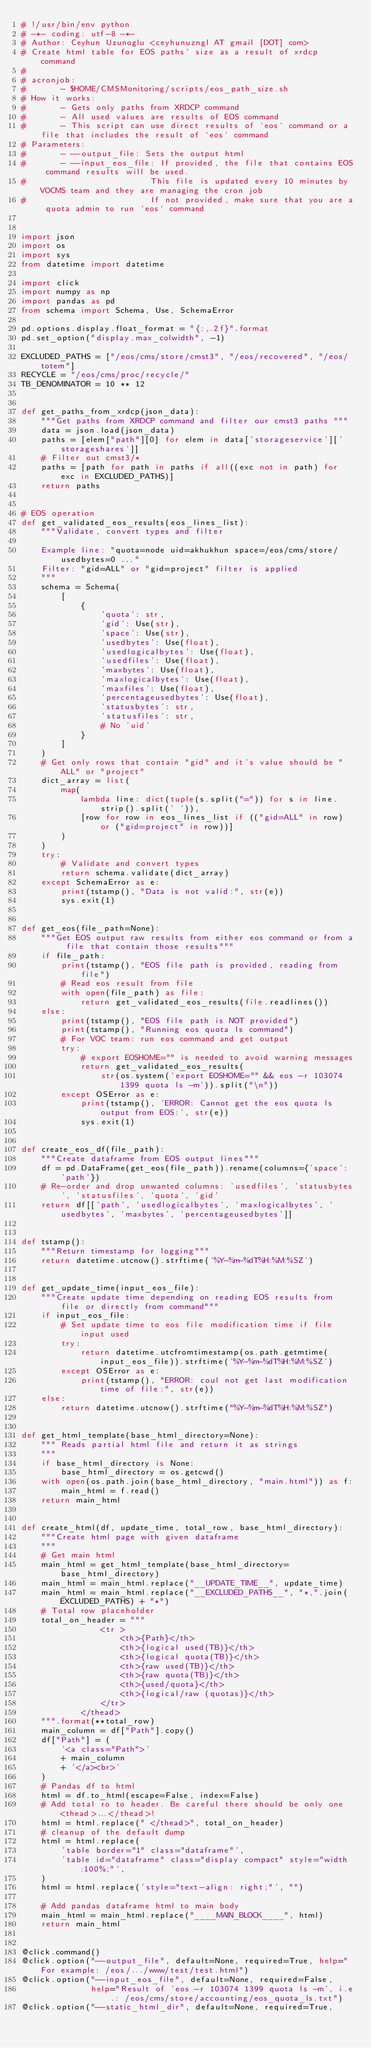Convert code to text. <code><loc_0><loc_0><loc_500><loc_500><_Python_># !/usr/bin/env python
# -*- coding: utf-8 -*-
# Author: Ceyhun Uzunoglu <ceyhunuzngl AT gmail [DOT] com>
# Create html table for EOS paths' size as a result of xrdcp command
#
# acronjob:
#       - $HOME/CMSMonitoring/scripts/eos_path_size.sh
# How it works:
#       - Gets only paths from XRDCP command
#       - All used values are results of EOS command
#       - This script can use direct results of `eos` command or a file that includes the result of `eos` command
# Parameters:
#       - --output_file: Sets the output html
#       - --input_eos_file: If provided, the file that contains EOS command results will be used.
#                         This file is updated every 10 minutes by VOCMS team and they are managing the cron job
#                         If not provided, make sure that you are a quota admin to run `eos` command


import json
import os
import sys
from datetime import datetime

import click
import numpy as np
import pandas as pd
from schema import Schema, Use, SchemaError

pd.options.display.float_format = "{:,.2f}".format
pd.set_option("display.max_colwidth", -1)

EXCLUDED_PATHS = ["/eos/cms/store/cmst3", "/eos/recovered", "/eos/totem"]
RECYCLE = "/eos/cms/proc/recycle/"
TB_DENOMINATOR = 10 ** 12


def get_paths_from_xrdcp(json_data):
    """Get paths from XRDCP command and filter our cmst3 paths """
    data = json.load(json_data)
    paths = [elem["path"][0] for elem in data['storageservice']['storageshares']]
    # Filter out cmst3/*
    paths = [path for path in paths if all((exc not in path) for exc in EXCLUDED_PATHS)]
    return paths


# EOS operation
def get_validated_eos_results(eos_lines_list):
    """Validate, convert types and filter

    Example line: "quota=node uid=akhukhun space=/eos/cms/store/ usedbytes=0 ..."
    Filter: "gid=ALL" or "gid=project" filter is applied
    """
    schema = Schema(
        [
            {
                'quota': str,
                'gid': Use(str),
                'space': Use(str),
                'usedbytes': Use(float),
                'usedlogicalbytes': Use(float),
                'usedfiles': Use(float),
                'maxbytes': Use(float),
                'maxlogicalbytes': Use(float),
                'maxfiles': Use(float),
                'percentageusedbytes': Use(float),
                'statusbytes': str,
                'statusfiles': str,
                # No 'uid'
            }
        ]
    )
    # Get only rows that contain "gid" and it's value should be "ALL" or "project"
    dict_array = list(
        map(
            lambda line: dict(tuple(s.split("=")) for s in line.strip().split(' ')),
            [row for row in eos_lines_list if (("gid=ALL" in row) or ("gid=project" in row))]
        )
    )
    try:
        # Validate and convert types
        return schema.validate(dict_array)
    except SchemaError as e:
        print(tstamp(), "Data is not valid:", str(e))
        sys.exit(1)


def get_eos(file_path=None):
    """Get EOS output raw results from either eos command or from a file that contain those results"""
    if file_path:
        print(tstamp(), "EOS file path is provided, reading from file")
        # Read eos result from file
        with open(file_path) as file:
            return get_validated_eos_results(file.readlines())
    else:
        print(tstamp(), "EOS file path is NOT provided")
        print(tstamp(), "Running eos quota ls command")
        # For VOC team: run eos command and get output
        try:
            # export EOSHOME="" is needed to avoid warning messages
            return get_validated_eos_results(
                str(os.system('export EOSHOME="" && eos -r 103074 1399 quota ls -m')).split("\n"))
        except OSError as e:
            print(tstamp(), 'ERROR: Cannot get the eos quota ls output from EOS:', str(e))
            sys.exit(1)


def create_eos_df(file_path):
    """Create dataframe from EOS output lines"""
    df = pd.DataFrame(get_eos(file_path)).rename(columns={'space': 'path'})
    # Re-order and drop unwanted columns: 'usedfiles', 'statusbytes', 'statusfiles', 'quota', 'gid'
    return df[['path', 'usedlogicalbytes', 'maxlogicalbytes', 'usedbytes', 'maxbytes', 'percentageusedbytes']]


def tstamp():
    """Return timestamp for logging"""
    return datetime.utcnow().strftime('%Y-%m-%dT%H:%M:%SZ')


def get_update_time(input_eos_file):
    """Create update time depending on reading EOS results from file or directly from command"""
    if input_eos_file:
        # Set update time to eos file modification time if file input used
        try:
            return datetime.utcfromtimestamp(os.path.getmtime(input_eos_file)).strftime('%Y-%m-%dT%H:%M:%SZ')
        except OSError as e:
            print(tstamp(), "ERROR: coul not get last modification time of file:", str(e))
    else:
        return datetime.utcnow().strftime("%Y-%m-%dT%H:%M:%SZ")


def get_html_template(base_html_directory=None):
    """ Reads partial html file and return it as strings
    """
    if base_html_directory is None:
        base_html_directory = os.getcwd()
    with open(os.path.join(base_html_directory, "main.html")) as f:
        main_html = f.read()
    return main_html


def create_html(df, update_time, total_row, base_html_directory):
    """Create html page with given dataframe
    """
    # Get main html
    main_html = get_html_template(base_html_directory=base_html_directory)
    main_html = main_html.replace("__UPDATE_TIME__", update_time)
    main_html = main_html.replace("__EXCLUDED_PATHS__", "*,".join(EXCLUDED_PATHS) + "*")
    # Total row placeholder
    total_on_header = """
                <tr >
                    <th>{Path}</th>
                    <th>{logical used(TB)}</th>
                    <th>{logical quota(TB)}</th>
                    <th>{raw used(TB)}</th>
                    <th>{raw quota(TB)}</th>
                    <th>{used/quota}</th>
                    <th>{logical/raw (quotas)}</th>
                </tr>
            </thead>
    """.format(**total_row)
    main_column = df["Path"].copy()
    df["Path"] = (
        '<a class="Path">'
        + main_column
        + '</a><br>'
    )
    # Pandas df to html
    html = df.to_html(escape=False, index=False)
    # Add total ro to header. Be careful there should be only one  <thead>...</thead>!
    html = html.replace(" </thead>", total_on_header)
    # cleanup of the default dump
    html = html.replace(
        'table border="1" class="dataframe"',
        'table id="dataframe" class="display compact" style="width:100%;"',
    )
    html = html.replace('style="text-align: right;"', "")

    # Add pandas dataframe html to main body
    main_html = main_html.replace("____MAIN_BLOCK____", html)
    return main_html


@click.command()
@click.option("--output_file", default=None, required=True, help="For example: /eos/.../www/test/test.html")
@click.option("--input_eos_file", default=None, required=False,
              help="Result of 'eos -r 103074 1399 quota ls -m', i.e.: /eos/cms/store/accounting/eos_quota_ls.txt")
@click.option("--static_html_dir", default=None, required=True,</code> 